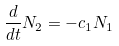Convert formula to latex. <formula><loc_0><loc_0><loc_500><loc_500>\frac { d } { d t } N _ { 2 } = - c _ { 1 } N _ { 1 }</formula> 